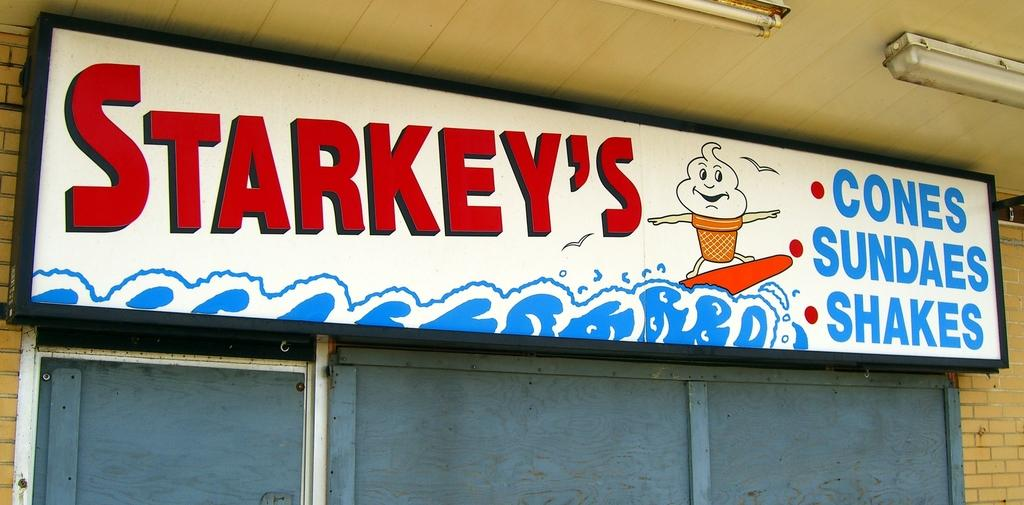Provide a one-sentence caption for the provided image. A sign for a restaurant named Starkey's with an ice cream surfing on a wave. 